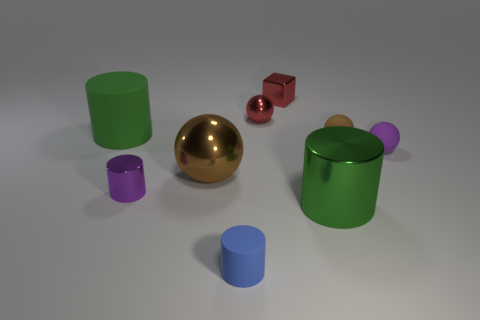Add 1 small purple matte spheres. How many objects exist? 10 Subtract all cylinders. How many objects are left? 5 Add 8 small red things. How many small red things exist? 10 Subtract 0 blue spheres. How many objects are left? 9 Subtract all large blue spheres. Subtract all tiny shiny blocks. How many objects are left? 8 Add 7 blue rubber things. How many blue rubber things are left? 8 